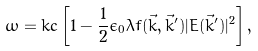Convert formula to latex. <formula><loc_0><loc_0><loc_500><loc_500>\omega = k c \left [ 1 - \frac { 1 } { 2 } \epsilon _ { 0 } \lambda f ( \vec { k } , \vec { k } ^ { \prime } ) | E ( \vec { k } ^ { \prime } ) | ^ { 2 } \right ] ,</formula> 